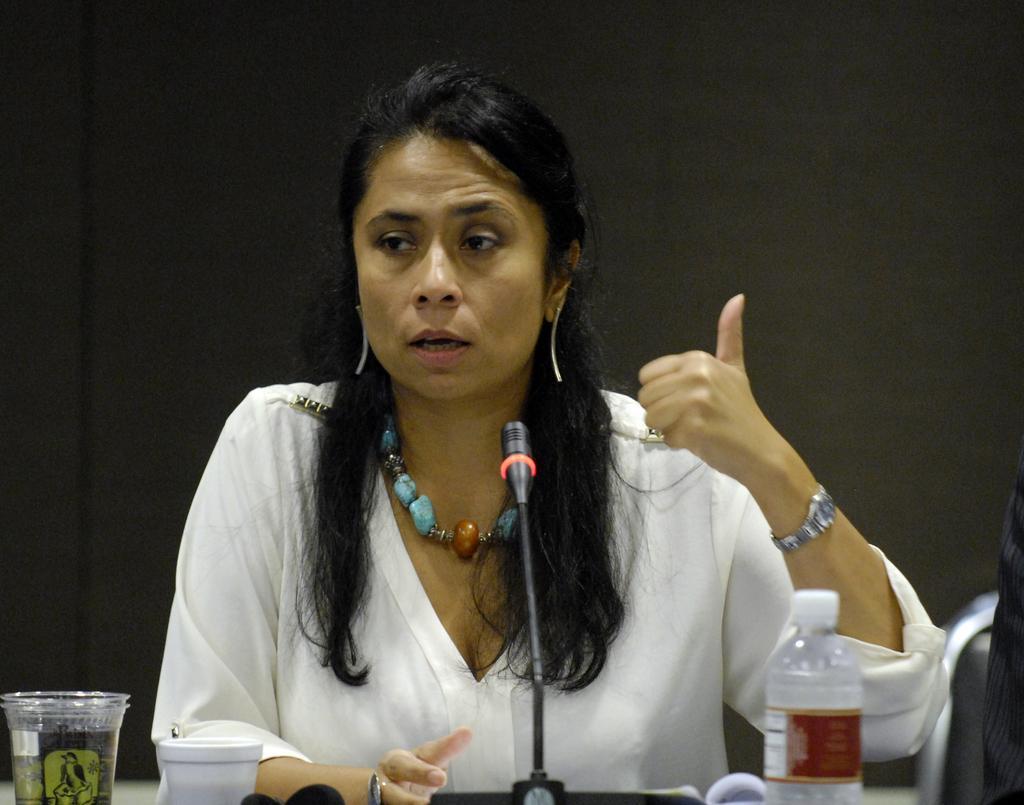In one or two sentences, can you explain what this image depicts? In the image a lady wearing a white shirt is talking something. In front of her there is a mic, bottle,glasses. In the background there is a curtain. 